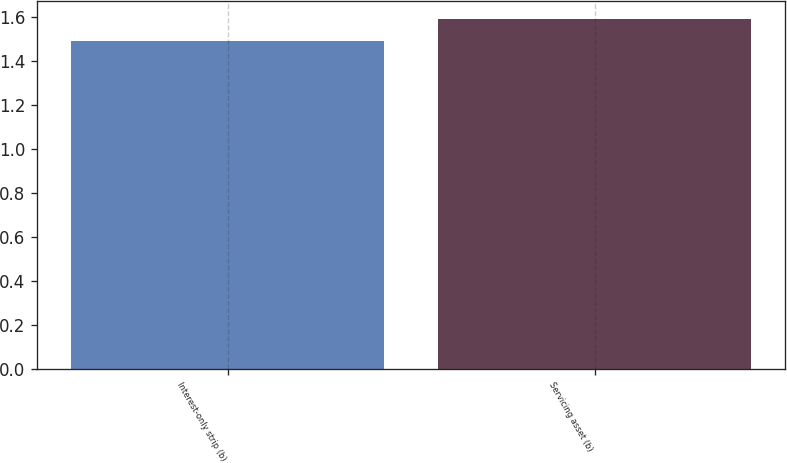Convert chart. <chart><loc_0><loc_0><loc_500><loc_500><bar_chart><fcel>Interest-only strip (b)<fcel>Servicing asset (b)<nl><fcel>1.49<fcel>1.59<nl></chart> 